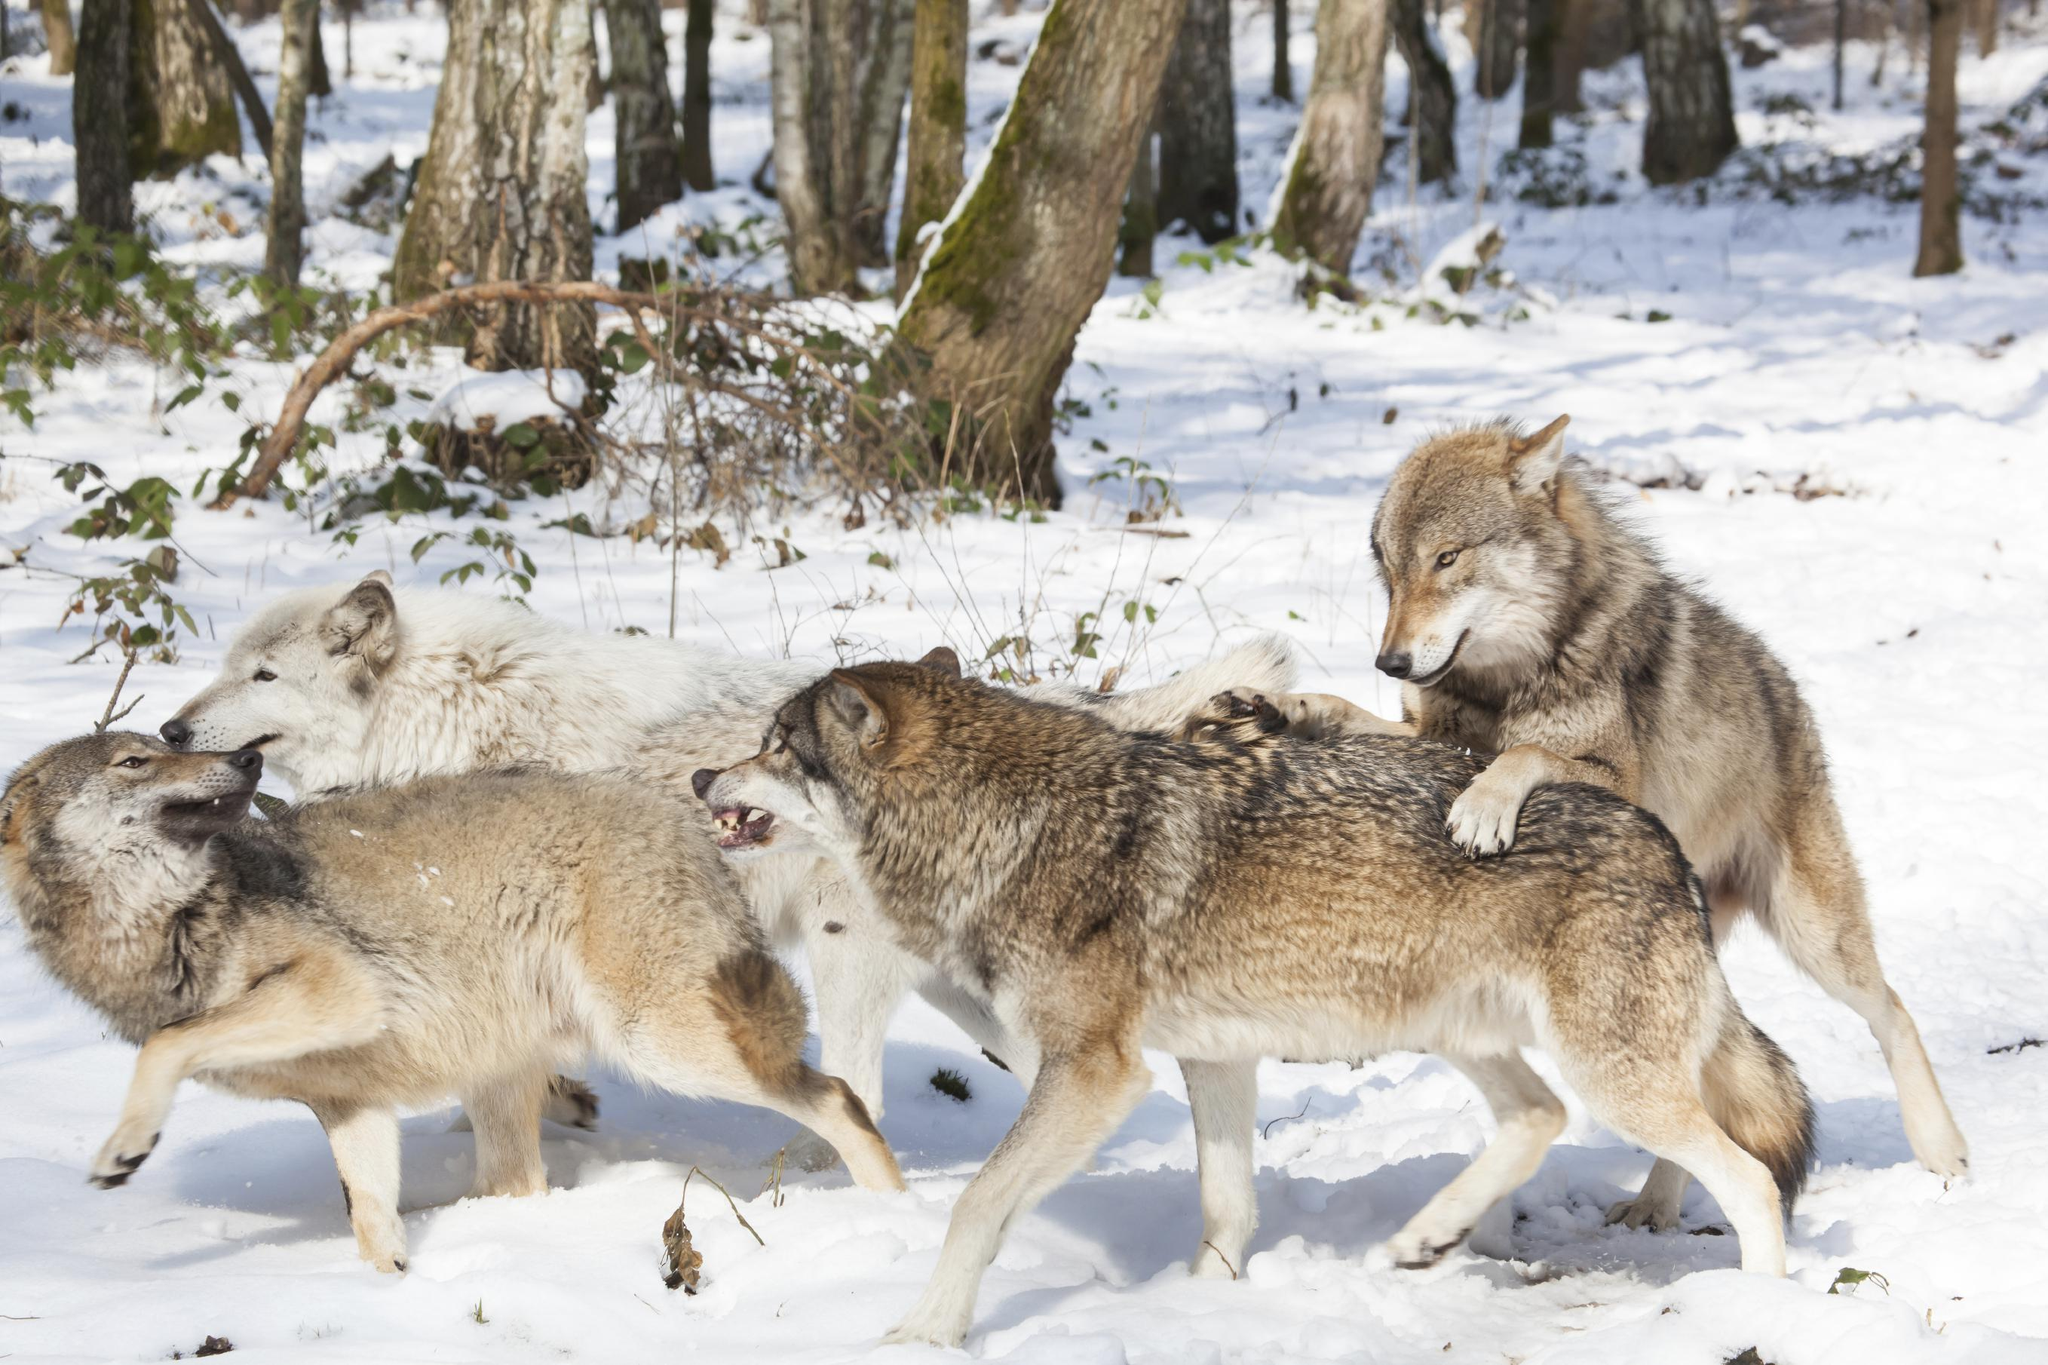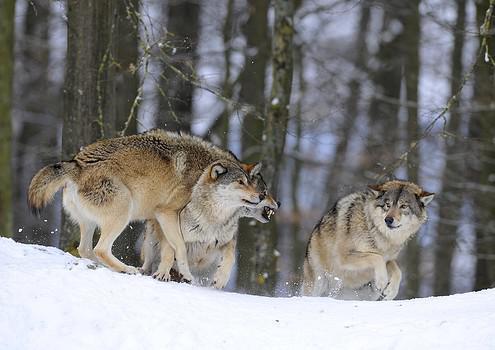The first image is the image on the left, the second image is the image on the right. Evaluate the accuracy of this statement regarding the images: "The right image contains exactly two wolves.". Is it true? Answer yes or no. No. The first image is the image on the left, the second image is the image on the right. Analyze the images presented: Is the assertion "One image shows a single wolf in confrontation with a group of wolves that outnumber it about 5-to1." valid? Answer yes or no. No. 